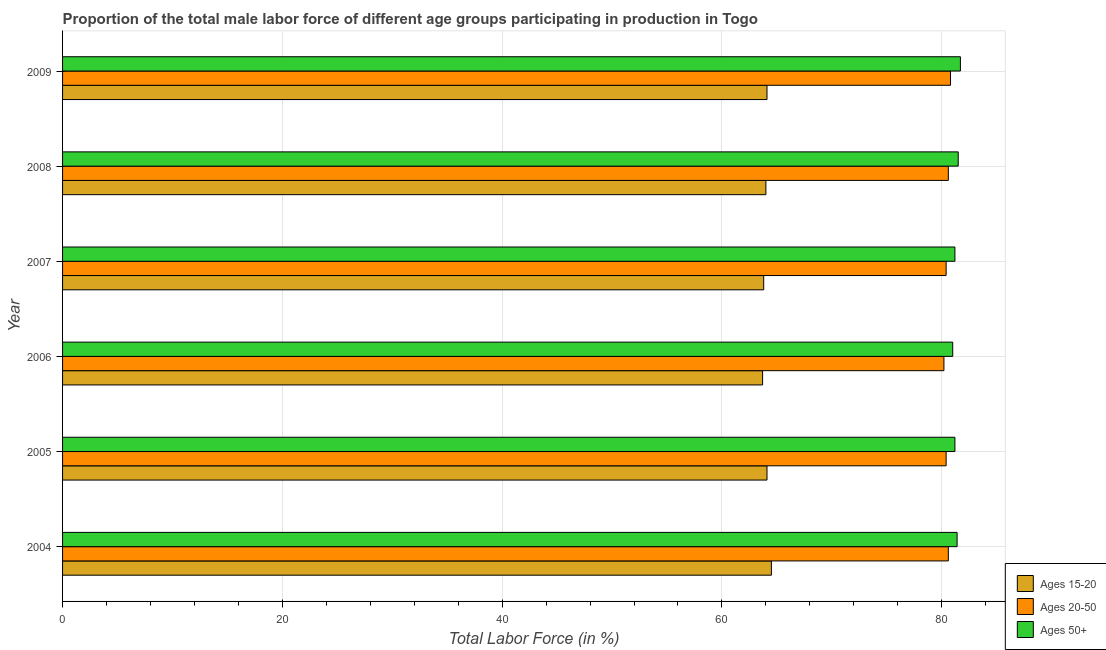How many bars are there on the 6th tick from the top?
Provide a short and direct response. 3. How many bars are there on the 6th tick from the bottom?
Your answer should be compact. 3. What is the percentage of male labor force above age 50 in 2009?
Make the answer very short. 81.7. Across all years, what is the maximum percentage of male labor force above age 50?
Give a very brief answer. 81.7. In which year was the percentage of male labor force within the age group 20-50 maximum?
Provide a succinct answer. 2009. What is the total percentage of male labor force within the age group 20-50 in the graph?
Ensure brevity in your answer.  483. What is the difference between the percentage of male labor force within the age group 15-20 in 2007 and the percentage of male labor force within the age group 20-50 in 2005?
Ensure brevity in your answer.  -16.6. What is the average percentage of male labor force within the age group 15-20 per year?
Offer a very short reply. 64.03. In the year 2004, what is the difference between the percentage of male labor force within the age group 15-20 and percentage of male labor force above age 50?
Your answer should be very brief. -16.9. Is the percentage of male labor force within the age group 15-20 in 2005 less than that in 2009?
Your answer should be compact. No. In how many years, is the percentage of male labor force within the age group 20-50 greater than the average percentage of male labor force within the age group 20-50 taken over all years?
Make the answer very short. 3. What does the 1st bar from the top in 2004 represents?
Ensure brevity in your answer.  Ages 50+. What does the 2nd bar from the bottom in 2009 represents?
Provide a short and direct response. Ages 20-50. Is it the case that in every year, the sum of the percentage of male labor force within the age group 15-20 and percentage of male labor force within the age group 20-50 is greater than the percentage of male labor force above age 50?
Your answer should be very brief. Yes. How many bars are there?
Keep it short and to the point. 18. Are all the bars in the graph horizontal?
Your response must be concise. Yes. How many years are there in the graph?
Ensure brevity in your answer.  6. Where does the legend appear in the graph?
Give a very brief answer. Bottom right. How many legend labels are there?
Ensure brevity in your answer.  3. What is the title of the graph?
Offer a terse response. Proportion of the total male labor force of different age groups participating in production in Togo. What is the label or title of the X-axis?
Give a very brief answer. Total Labor Force (in %). What is the label or title of the Y-axis?
Provide a succinct answer. Year. What is the Total Labor Force (in %) in Ages 15-20 in 2004?
Ensure brevity in your answer.  64.5. What is the Total Labor Force (in %) of Ages 20-50 in 2004?
Offer a very short reply. 80.6. What is the Total Labor Force (in %) in Ages 50+ in 2004?
Your answer should be compact. 81.4. What is the Total Labor Force (in %) of Ages 15-20 in 2005?
Offer a very short reply. 64.1. What is the Total Labor Force (in %) in Ages 20-50 in 2005?
Provide a succinct answer. 80.4. What is the Total Labor Force (in %) in Ages 50+ in 2005?
Provide a succinct answer. 81.2. What is the Total Labor Force (in %) in Ages 15-20 in 2006?
Your answer should be very brief. 63.7. What is the Total Labor Force (in %) of Ages 20-50 in 2006?
Provide a short and direct response. 80.2. What is the Total Labor Force (in %) in Ages 15-20 in 2007?
Ensure brevity in your answer.  63.8. What is the Total Labor Force (in %) of Ages 20-50 in 2007?
Provide a short and direct response. 80.4. What is the Total Labor Force (in %) in Ages 50+ in 2007?
Your answer should be compact. 81.2. What is the Total Labor Force (in %) of Ages 15-20 in 2008?
Your answer should be compact. 64. What is the Total Labor Force (in %) of Ages 20-50 in 2008?
Ensure brevity in your answer.  80.6. What is the Total Labor Force (in %) in Ages 50+ in 2008?
Keep it short and to the point. 81.5. What is the Total Labor Force (in %) in Ages 15-20 in 2009?
Ensure brevity in your answer.  64.1. What is the Total Labor Force (in %) of Ages 20-50 in 2009?
Make the answer very short. 80.8. What is the Total Labor Force (in %) of Ages 50+ in 2009?
Your answer should be compact. 81.7. Across all years, what is the maximum Total Labor Force (in %) in Ages 15-20?
Make the answer very short. 64.5. Across all years, what is the maximum Total Labor Force (in %) of Ages 20-50?
Keep it short and to the point. 80.8. Across all years, what is the maximum Total Labor Force (in %) of Ages 50+?
Your answer should be compact. 81.7. Across all years, what is the minimum Total Labor Force (in %) of Ages 15-20?
Provide a succinct answer. 63.7. Across all years, what is the minimum Total Labor Force (in %) in Ages 20-50?
Your response must be concise. 80.2. What is the total Total Labor Force (in %) of Ages 15-20 in the graph?
Your answer should be very brief. 384.2. What is the total Total Labor Force (in %) in Ages 20-50 in the graph?
Your answer should be very brief. 483. What is the total Total Labor Force (in %) of Ages 50+ in the graph?
Provide a succinct answer. 488. What is the difference between the Total Labor Force (in %) of Ages 15-20 in 2004 and that in 2005?
Ensure brevity in your answer.  0.4. What is the difference between the Total Labor Force (in %) of Ages 20-50 in 2004 and that in 2005?
Offer a terse response. 0.2. What is the difference between the Total Labor Force (in %) in Ages 50+ in 2004 and that in 2005?
Offer a very short reply. 0.2. What is the difference between the Total Labor Force (in %) of Ages 20-50 in 2004 and that in 2006?
Offer a terse response. 0.4. What is the difference between the Total Labor Force (in %) of Ages 20-50 in 2004 and that in 2007?
Ensure brevity in your answer.  0.2. What is the difference between the Total Labor Force (in %) in Ages 50+ in 2004 and that in 2007?
Provide a succinct answer. 0.2. What is the difference between the Total Labor Force (in %) of Ages 15-20 in 2004 and that in 2008?
Your response must be concise. 0.5. What is the difference between the Total Labor Force (in %) in Ages 20-50 in 2004 and that in 2008?
Keep it short and to the point. 0. What is the difference between the Total Labor Force (in %) of Ages 15-20 in 2004 and that in 2009?
Offer a very short reply. 0.4. What is the difference between the Total Labor Force (in %) in Ages 20-50 in 2004 and that in 2009?
Offer a very short reply. -0.2. What is the difference between the Total Labor Force (in %) in Ages 50+ in 2005 and that in 2006?
Your response must be concise. 0.2. What is the difference between the Total Labor Force (in %) of Ages 20-50 in 2005 and that in 2007?
Your response must be concise. 0. What is the difference between the Total Labor Force (in %) of Ages 50+ in 2005 and that in 2007?
Ensure brevity in your answer.  0. What is the difference between the Total Labor Force (in %) of Ages 15-20 in 2005 and that in 2008?
Give a very brief answer. 0.1. What is the difference between the Total Labor Force (in %) of Ages 50+ in 2005 and that in 2008?
Give a very brief answer. -0.3. What is the difference between the Total Labor Force (in %) in Ages 50+ in 2005 and that in 2009?
Make the answer very short. -0.5. What is the difference between the Total Labor Force (in %) of Ages 15-20 in 2006 and that in 2007?
Provide a succinct answer. -0.1. What is the difference between the Total Labor Force (in %) of Ages 15-20 in 2006 and that in 2008?
Offer a very short reply. -0.3. What is the difference between the Total Labor Force (in %) in Ages 20-50 in 2006 and that in 2008?
Provide a short and direct response. -0.4. What is the difference between the Total Labor Force (in %) of Ages 20-50 in 2006 and that in 2009?
Keep it short and to the point. -0.6. What is the difference between the Total Labor Force (in %) of Ages 20-50 in 2007 and that in 2008?
Offer a very short reply. -0.2. What is the difference between the Total Labor Force (in %) of Ages 50+ in 2007 and that in 2008?
Your answer should be compact. -0.3. What is the difference between the Total Labor Force (in %) in Ages 20-50 in 2007 and that in 2009?
Your response must be concise. -0.4. What is the difference between the Total Labor Force (in %) of Ages 50+ in 2007 and that in 2009?
Ensure brevity in your answer.  -0.5. What is the difference between the Total Labor Force (in %) in Ages 15-20 in 2008 and that in 2009?
Your answer should be very brief. -0.1. What is the difference between the Total Labor Force (in %) in Ages 20-50 in 2008 and that in 2009?
Offer a very short reply. -0.2. What is the difference between the Total Labor Force (in %) of Ages 15-20 in 2004 and the Total Labor Force (in %) of Ages 20-50 in 2005?
Make the answer very short. -15.9. What is the difference between the Total Labor Force (in %) in Ages 15-20 in 2004 and the Total Labor Force (in %) in Ages 50+ in 2005?
Offer a terse response. -16.7. What is the difference between the Total Labor Force (in %) in Ages 15-20 in 2004 and the Total Labor Force (in %) in Ages 20-50 in 2006?
Make the answer very short. -15.7. What is the difference between the Total Labor Force (in %) in Ages 15-20 in 2004 and the Total Labor Force (in %) in Ages 50+ in 2006?
Give a very brief answer. -16.5. What is the difference between the Total Labor Force (in %) in Ages 20-50 in 2004 and the Total Labor Force (in %) in Ages 50+ in 2006?
Offer a terse response. -0.4. What is the difference between the Total Labor Force (in %) in Ages 15-20 in 2004 and the Total Labor Force (in %) in Ages 20-50 in 2007?
Your answer should be very brief. -15.9. What is the difference between the Total Labor Force (in %) in Ages 15-20 in 2004 and the Total Labor Force (in %) in Ages 50+ in 2007?
Offer a terse response. -16.7. What is the difference between the Total Labor Force (in %) of Ages 20-50 in 2004 and the Total Labor Force (in %) of Ages 50+ in 2007?
Give a very brief answer. -0.6. What is the difference between the Total Labor Force (in %) of Ages 15-20 in 2004 and the Total Labor Force (in %) of Ages 20-50 in 2008?
Your answer should be very brief. -16.1. What is the difference between the Total Labor Force (in %) of Ages 15-20 in 2004 and the Total Labor Force (in %) of Ages 20-50 in 2009?
Your answer should be very brief. -16.3. What is the difference between the Total Labor Force (in %) in Ages 15-20 in 2004 and the Total Labor Force (in %) in Ages 50+ in 2009?
Offer a very short reply. -17.2. What is the difference between the Total Labor Force (in %) in Ages 20-50 in 2004 and the Total Labor Force (in %) in Ages 50+ in 2009?
Your answer should be compact. -1.1. What is the difference between the Total Labor Force (in %) in Ages 15-20 in 2005 and the Total Labor Force (in %) in Ages 20-50 in 2006?
Give a very brief answer. -16.1. What is the difference between the Total Labor Force (in %) in Ages 15-20 in 2005 and the Total Labor Force (in %) in Ages 50+ in 2006?
Your response must be concise. -16.9. What is the difference between the Total Labor Force (in %) in Ages 15-20 in 2005 and the Total Labor Force (in %) in Ages 20-50 in 2007?
Your response must be concise. -16.3. What is the difference between the Total Labor Force (in %) of Ages 15-20 in 2005 and the Total Labor Force (in %) of Ages 50+ in 2007?
Ensure brevity in your answer.  -17.1. What is the difference between the Total Labor Force (in %) of Ages 15-20 in 2005 and the Total Labor Force (in %) of Ages 20-50 in 2008?
Offer a very short reply. -16.5. What is the difference between the Total Labor Force (in %) in Ages 15-20 in 2005 and the Total Labor Force (in %) in Ages 50+ in 2008?
Keep it short and to the point. -17.4. What is the difference between the Total Labor Force (in %) of Ages 15-20 in 2005 and the Total Labor Force (in %) of Ages 20-50 in 2009?
Your answer should be compact. -16.7. What is the difference between the Total Labor Force (in %) of Ages 15-20 in 2005 and the Total Labor Force (in %) of Ages 50+ in 2009?
Your answer should be very brief. -17.6. What is the difference between the Total Labor Force (in %) of Ages 20-50 in 2005 and the Total Labor Force (in %) of Ages 50+ in 2009?
Offer a terse response. -1.3. What is the difference between the Total Labor Force (in %) of Ages 15-20 in 2006 and the Total Labor Force (in %) of Ages 20-50 in 2007?
Give a very brief answer. -16.7. What is the difference between the Total Labor Force (in %) of Ages 15-20 in 2006 and the Total Labor Force (in %) of Ages 50+ in 2007?
Give a very brief answer. -17.5. What is the difference between the Total Labor Force (in %) in Ages 20-50 in 2006 and the Total Labor Force (in %) in Ages 50+ in 2007?
Keep it short and to the point. -1. What is the difference between the Total Labor Force (in %) of Ages 15-20 in 2006 and the Total Labor Force (in %) of Ages 20-50 in 2008?
Your answer should be very brief. -16.9. What is the difference between the Total Labor Force (in %) in Ages 15-20 in 2006 and the Total Labor Force (in %) in Ages 50+ in 2008?
Your response must be concise. -17.8. What is the difference between the Total Labor Force (in %) of Ages 20-50 in 2006 and the Total Labor Force (in %) of Ages 50+ in 2008?
Make the answer very short. -1.3. What is the difference between the Total Labor Force (in %) in Ages 15-20 in 2006 and the Total Labor Force (in %) in Ages 20-50 in 2009?
Provide a succinct answer. -17.1. What is the difference between the Total Labor Force (in %) in Ages 15-20 in 2007 and the Total Labor Force (in %) in Ages 20-50 in 2008?
Provide a succinct answer. -16.8. What is the difference between the Total Labor Force (in %) in Ages 15-20 in 2007 and the Total Labor Force (in %) in Ages 50+ in 2008?
Your answer should be very brief. -17.7. What is the difference between the Total Labor Force (in %) of Ages 20-50 in 2007 and the Total Labor Force (in %) of Ages 50+ in 2008?
Your answer should be very brief. -1.1. What is the difference between the Total Labor Force (in %) in Ages 15-20 in 2007 and the Total Labor Force (in %) in Ages 50+ in 2009?
Make the answer very short. -17.9. What is the difference between the Total Labor Force (in %) of Ages 20-50 in 2007 and the Total Labor Force (in %) of Ages 50+ in 2009?
Your response must be concise. -1.3. What is the difference between the Total Labor Force (in %) of Ages 15-20 in 2008 and the Total Labor Force (in %) of Ages 20-50 in 2009?
Provide a succinct answer. -16.8. What is the difference between the Total Labor Force (in %) in Ages 15-20 in 2008 and the Total Labor Force (in %) in Ages 50+ in 2009?
Give a very brief answer. -17.7. What is the average Total Labor Force (in %) in Ages 15-20 per year?
Offer a terse response. 64.03. What is the average Total Labor Force (in %) in Ages 20-50 per year?
Make the answer very short. 80.5. What is the average Total Labor Force (in %) in Ages 50+ per year?
Ensure brevity in your answer.  81.33. In the year 2004, what is the difference between the Total Labor Force (in %) in Ages 15-20 and Total Labor Force (in %) in Ages 20-50?
Provide a short and direct response. -16.1. In the year 2004, what is the difference between the Total Labor Force (in %) of Ages 15-20 and Total Labor Force (in %) of Ages 50+?
Your answer should be very brief. -16.9. In the year 2005, what is the difference between the Total Labor Force (in %) in Ages 15-20 and Total Labor Force (in %) in Ages 20-50?
Offer a terse response. -16.3. In the year 2005, what is the difference between the Total Labor Force (in %) in Ages 15-20 and Total Labor Force (in %) in Ages 50+?
Your answer should be very brief. -17.1. In the year 2006, what is the difference between the Total Labor Force (in %) in Ages 15-20 and Total Labor Force (in %) in Ages 20-50?
Your response must be concise. -16.5. In the year 2006, what is the difference between the Total Labor Force (in %) of Ages 15-20 and Total Labor Force (in %) of Ages 50+?
Your answer should be compact. -17.3. In the year 2007, what is the difference between the Total Labor Force (in %) of Ages 15-20 and Total Labor Force (in %) of Ages 20-50?
Give a very brief answer. -16.6. In the year 2007, what is the difference between the Total Labor Force (in %) of Ages 15-20 and Total Labor Force (in %) of Ages 50+?
Your answer should be compact. -17.4. In the year 2007, what is the difference between the Total Labor Force (in %) of Ages 20-50 and Total Labor Force (in %) of Ages 50+?
Keep it short and to the point. -0.8. In the year 2008, what is the difference between the Total Labor Force (in %) of Ages 15-20 and Total Labor Force (in %) of Ages 20-50?
Provide a succinct answer. -16.6. In the year 2008, what is the difference between the Total Labor Force (in %) in Ages 15-20 and Total Labor Force (in %) in Ages 50+?
Provide a succinct answer. -17.5. In the year 2009, what is the difference between the Total Labor Force (in %) of Ages 15-20 and Total Labor Force (in %) of Ages 20-50?
Your answer should be very brief. -16.7. In the year 2009, what is the difference between the Total Labor Force (in %) of Ages 15-20 and Total Labor Force (in %) of Ages 50+?
Your answer should be very brief. -17.6. In the year 2009, what is the difference between the Total Labor Force (in %) in Ages 20-50 and Total Labor Force (in %) in Ages 50+?
Give a very brief answer. -0.9. What is the ratio of the Total Labor Force (in %) of Ages 20-50 in 2004 to that in 2005?
Make the answer very short. 1. What is the ratio of the Total Labor Force (in %) in Ages 15-20 in 2004 to that in 2006?
Your answer should be compact. 1.01. What is the ratio of the Total Labor Force (in %) in Ages 20-50 in 2004 to that in 2006?
Make the answer very short. 1. What is the ratio of the Total Labor Force (in %) in Ages 50+ in 2004 to that in 2006?
Your answer should be very brief. 1. What is the ratio of the Total Labor Force (in %) of Ages 15-20 in 2004 to that in 2007?
Provide a short and direct response. 1.01. What is the ratio of the Total Labor Force (in %) in Ages 15-20 in 2004 to that in 2008?
Give a very brief answer. 1.01. What is the ratio of the Total Labor Force (in %) in Ages 20-50 in 2004 to that in 2008?
Provide a succinct answer. 1. What is the ratio of the Total Labor Force (in %) of Ages 20-50 in 2004 to that in 2009?
Your answer should be very brief. 1. What is the ratio of the Total Labor Force (in %) in Ages 20-50 in 2005 to that in 2006?
Make the answer very short. 1. What is the ratio of the Total Labor Force (in %) of Ages 50+ in 2005 to that in 2006?
Provide a short and direct response. 1. What is the ratio of the Total Labor Force (in %) in Ages 15-20 in 2005 to that in 2007?
Your answer should be compact. 1. What is the ratio of the Total Labor Force (in %) of Ages 20-50 in 2005 to that in 2007?
Give a very brief answer. 1. What is the ratio of the Total Labor Force (in %) in Ages 15-20 in 2005 to that in 2008?
Provide a succinct answer. 1. What is the ratio of the Total Labor Force (in %) of Ages 15-20 in 2005 to that in 2009?
Make the answer very short. 1. What is the ratio of the Total Labor Force (in %) in Ages 50+ in 2006 to that in 2007?
Give a very brief answer. 1. What is the ratio of the Total Labor Force (in %) in Ages 15-20 in 2006 to that in 2008?
Provide a succinct answer. 1. What is the ratio of the Total Labor Force (in %) in Ages 20-50 in 2006 to that in 2008?
Offer a terse response. 0.99. What is the ratio of the Total Labor Force (in %) in Ages 50+ in 2006 to that in 2008?
Give a very brief answer. 0.99. What is the ratio of the Total Labor Force (in %) in Ages 50+ in 2006 to that in 2009?
Offer a terse response. 0.99. What is the ratio of the Total Labor Force (in %) of Ages 15-20 in 2007 to that in 2008?
Your response must be concise. 1. What is the ratio of the Total Labor Force (in %) of Ages 20-50 in 2007 to that in 2008?
Offer a very short reply. 1. What is the ratio of the Total Labor Force (in %) of Ages 15-20 in 2007 to that in 2009?
Keep it short and to the point. 1. What is the ratio of the Total Labor Force (in %) in Ages 20-50 in 2007 to that in 2009?
Your answer should be very brief. 0.99. What is the difference between the highest and the lowest Total Labor Force (in %) in Ages 15-20?
Offer a terse response. 0.8. What is the difference between the highest and the lowest Total Labor Force (in %) in Ages 20-50?
Make the answer very short. 0.6. 